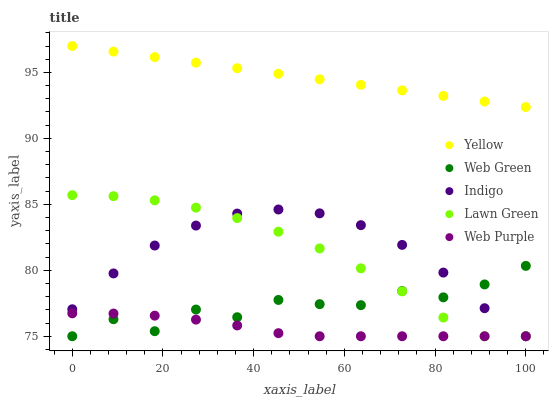Does Web Purple have the minimum area under the curve?
Answer yes or no. Yes. Does Yellow have the maximum area under the curve?
Answer yes or no. Yes. Does Indigo have the minimum area under the curve?
Answer yes or no. No. Does Indigo have the maximum area under the curve?
Answer yes or no. No. Is Yellow the smoothest?
Answer yes or no. Yes. Is Web Green the roughest?
Answer yes or no. Yes. Is Web Purple the smoothest?
Answer yes or no. No. Is Web Purple the roughest?
Answer yes or no. No. Does Lawn Green have the lowest value?
Answer yes or no. Yes. Does Yellow have the lowest value?
Answer yes or no. No. Does Yellow have the highest value?
Answer yes or no. Yes. Does Indigo have the highest value?
Answer yes or no. No. Is Lawn Green less than Yellow?
Answer yes or no. Yes. Is Yellow greater than Indigo?
Answer yes or no. Yes. Does Web Purple intersect Indigo?
Answer yes or no. Yes. Is Web Purple less than Indigo?
Answer yes or no. No. Is Web Purple greater than Indigo?
Answer yes or no. No. Does Lawn Green intersect Yellow?
Answer yes or no. No. 